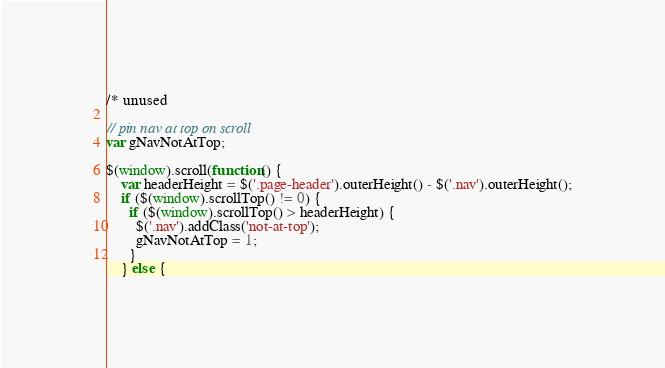Convert code to text. <code><loc_0><loc_0><loc_500><loc_500><_JavaScript_>/* unused

// pin nav at top on scroll
var gNavNotAtTop;

$(window).scroll(function() { 
    var headerHeight = $('.page-header').outerHeight() - $('.nav').outerHeight();
    if ($(window).scrollTop() != 0) {
      if ($(window).scrollTop() > headerHeight) { 
        $('.nav').addClass('not-at-top');
        gNavNotAtTop = 1;        
      }
    } else {</code> 